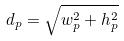Convert formula to latex. <formula><loc_0><loc_0><loc_500><loc_500>d _ { p } = \sqrt { w _ { p } ^ { 2 } + h _ { p } ^ { 2 } }</formula> 